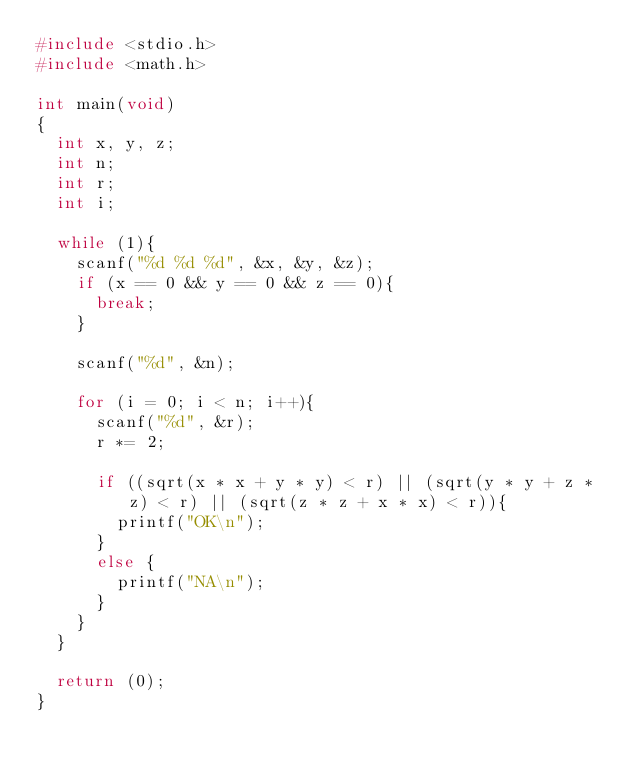<code> <loc_0><loc_0><loc_500><loc_500><_C_>#include <stdio.h>
#include <math.h>

int main(void)
{
	int x, y, z;
	int n;
	int r;
	int i;
	
	while (1){
		scanf("%d %d %d", &x, &y, &z);
		if (x == 0 && y == 0 && z == 0){
			break;
		}
		
		scanf("%d", &n);
		
		for (i = 0; i < n; i++){
			scanf("%d", &r);
			r *= 2;
			
			if ((sqrt(x * x + y * y) < r) || (sqrt(y * y + z * z) < r) || (sqrt(z * z + x * x) < r)){
				printf("OK\n");
			}
			else {
				printf("NA\n");
			}
		}
	}
	
	return (0);
}</code> 